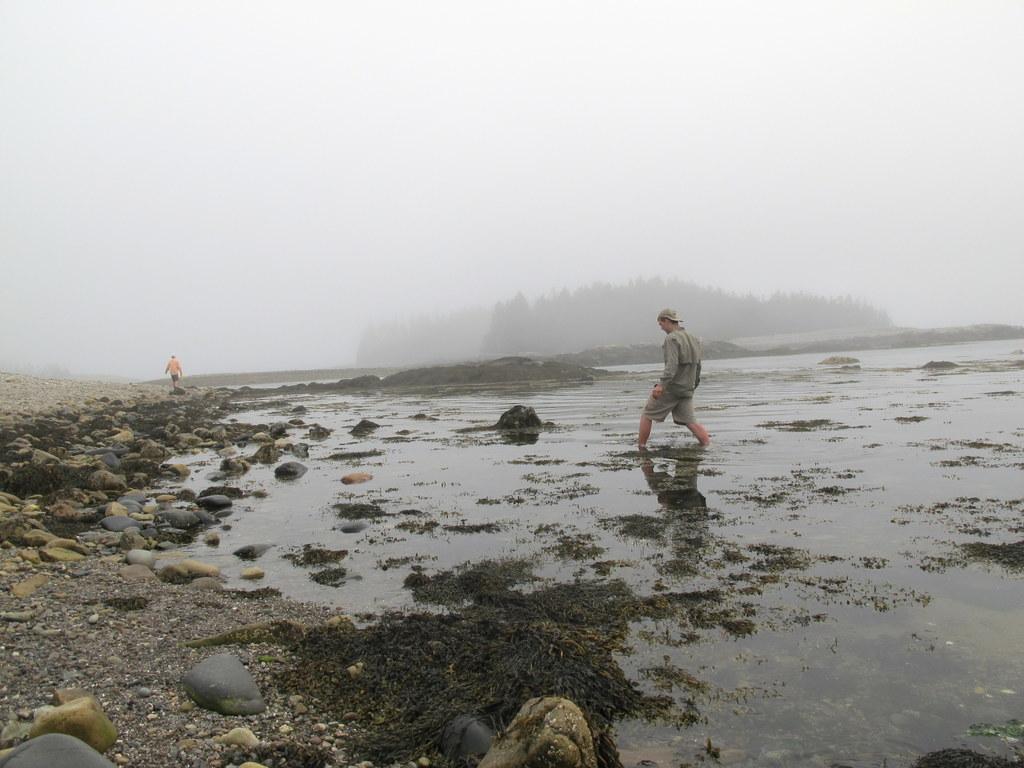Could you give a brief overview of what you see in this image? In this picture we can see a person is standing in the water and on the left side of the person there are stones and another person is walking on the path. In front of the people there are trees and fog. 